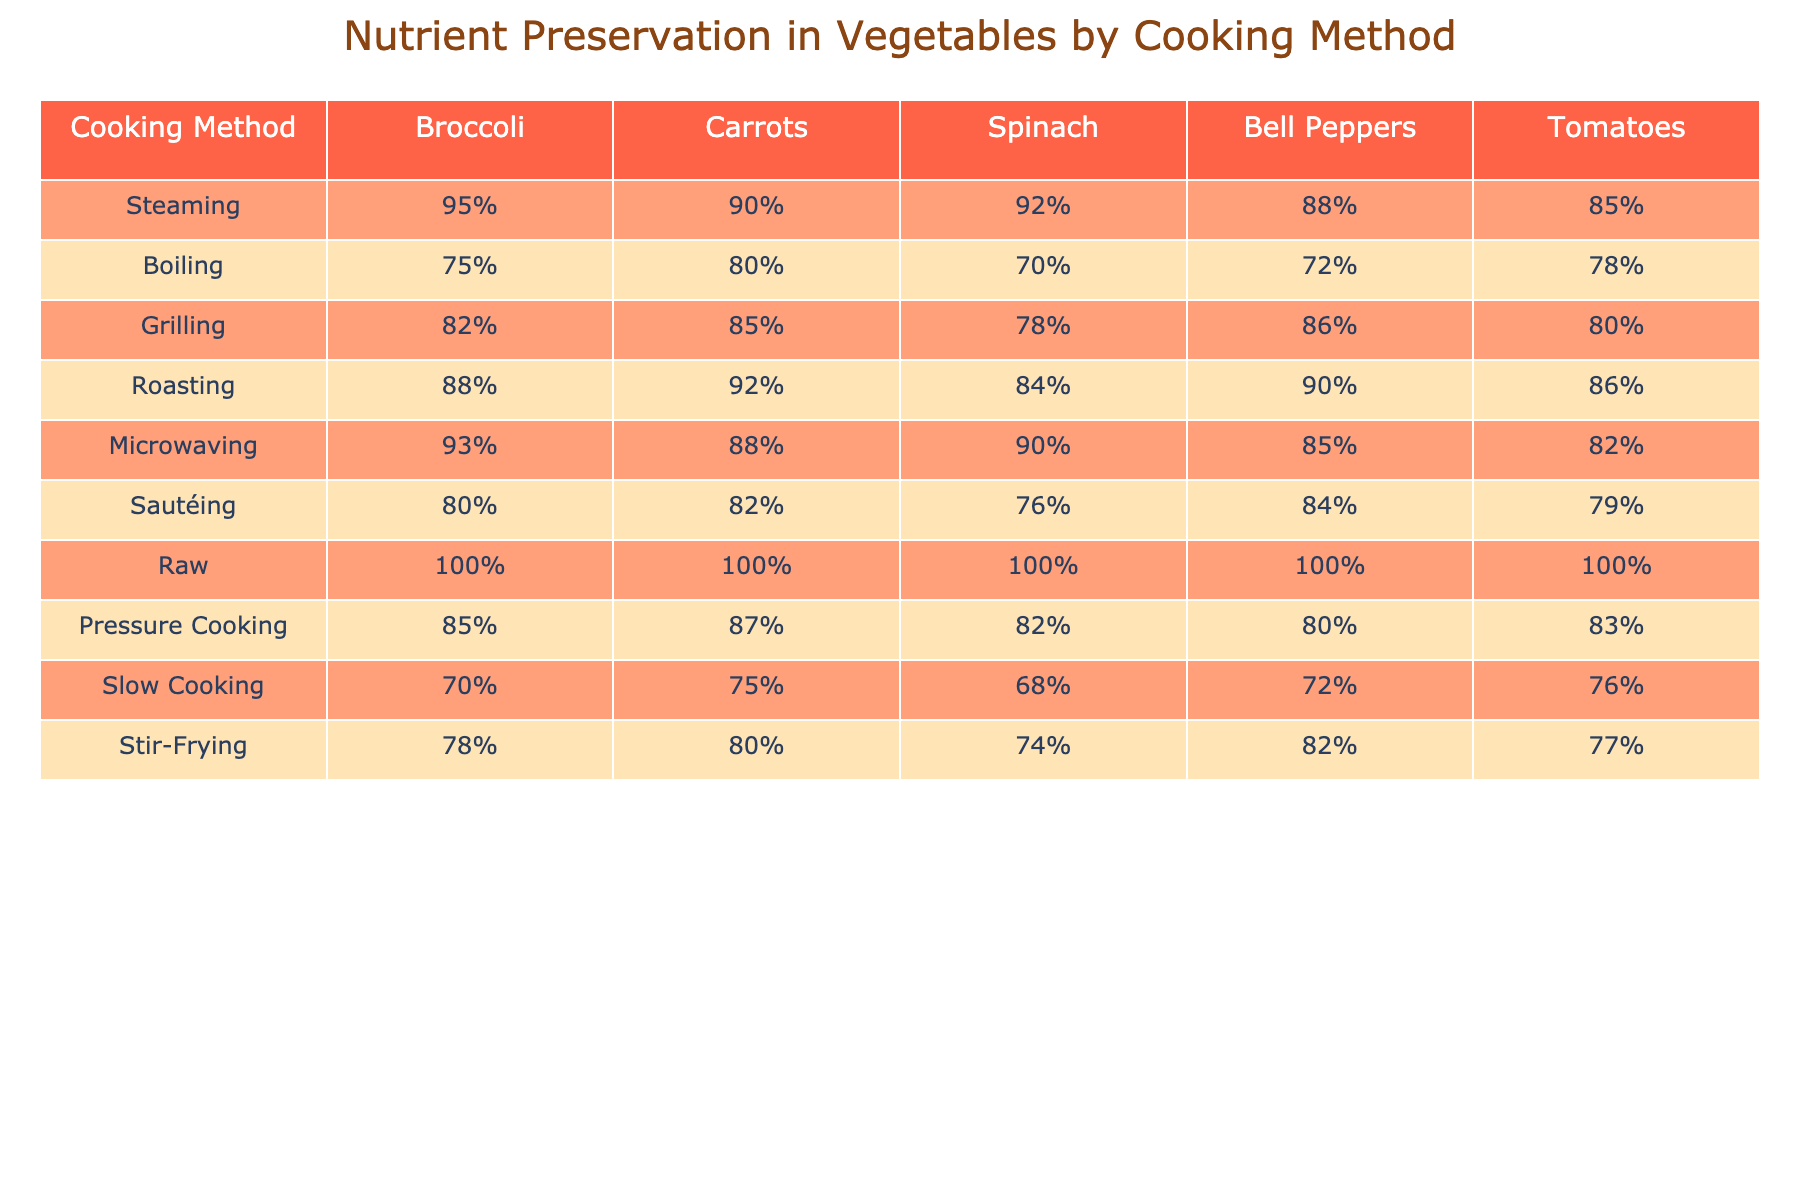What is the nutrient preservation percentage for broccoli when steamed? The nutrient preservation percentage for broccoli when steamed is explicitly listed in the table. It shows 95% for steaming.
Answer: 95% Which cooking method has the lowest nutrient preservation for carrots? The table shows the percentages for carrots across different cooking methods. The lowest value is for slow cooking at 75%.
Answer: 75% What is the average nutrient preservation percentage for spinach across all cooking methods? To find the average, we sum the values for spinach: 92 + 70 + 78 + 84 + 90 + 76 + 100 + 82 + 68 + 74 =  804. There are 10 methods, so the average is 804/10 = 80.4.
Answer: 80.4% Do bell peppers retain more nutrients when roasted or boiled? According to the table, bell peppers retain 90% of nutrients when roasted and 72% when boiled. Comparing these, roasting preserves more nutrients.
Answer: Roasted Which cooking method is the best for overall nutrient preservation in tomatoes? By comparing the nutrient preservation percentages for tomatoes, raw has the highest at 100%, followed by steaming at 85%. Thus, raw is best.
Answer: Raw If you combine the nutrient percentages for broccoli and carrots when grilled, what is their total? The grilling percentages for broccoli and carrots are 82% and 85%, respectively. Summing these, we get 82 + 85 = 167%.
Answer: 167% Is pressure cooking better for preserving nutrients in vegetables than sautéing? Pressure cooking for vegetables preserves 85%, 87%, 82%, 80%, and 83% for the respective vegetables, while sautéing preserves 80%, 82%, 76%, 84%, and 79%. Sautéing has lower percentages for all vegetables compared to pressure cooking, so pressure cooking is better.
Answer: Yes What is the difference in nutrient preservation percentage for tomatoes when microwaved versus grilled? The preservation percentage for tomatoes when microwaved is 82%, and when grilled it is 80%. The difference is 82 - 80 = 2%.
Answer: 2% Which two cooking methods achieve the same nutrient preservation percentage for spinach? In the table, both boiling and stir-frying have the same nutrient preservation percentage of 70% for spinach.
Answer: Boiling and Stir-Frying 